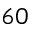<formula> <loc_0><loc_0><loc_500><loc_500>6 0</formula> 